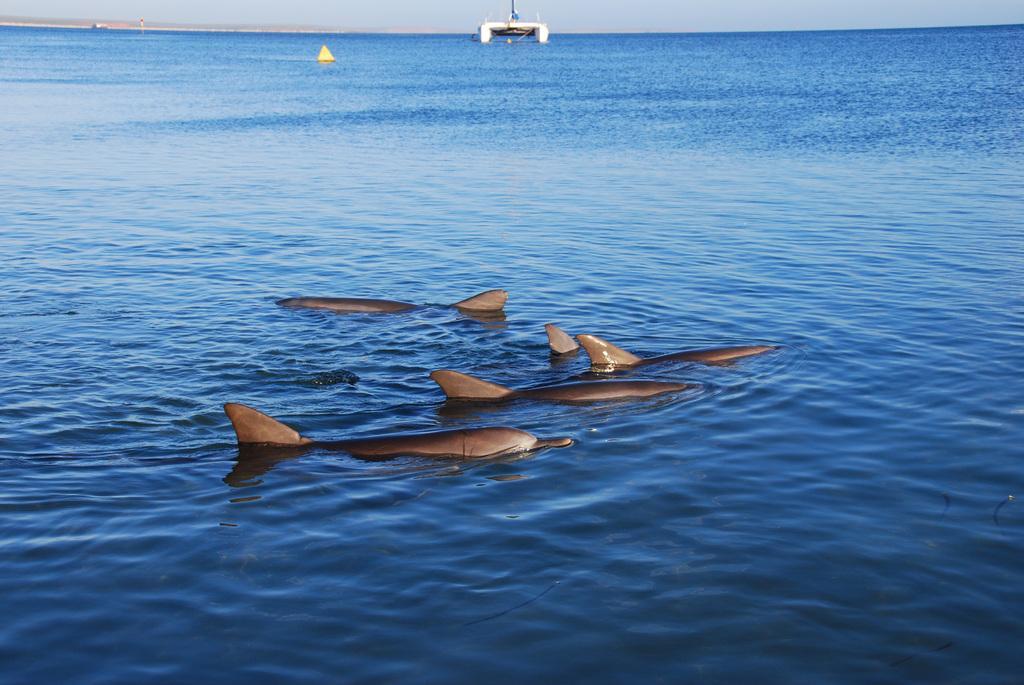How would you summarize this image in a sentence or two? In the image we can see there are fish in the water. Here we can see the sea and an object in the water and the sky. 